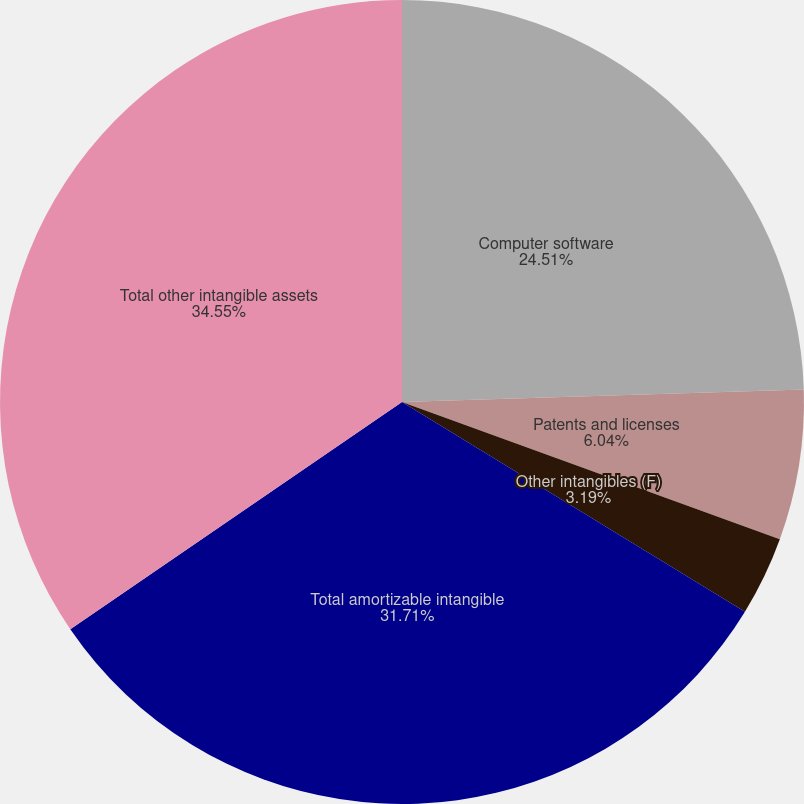<chart> <loc_0><loc_0><loc_500><loc_500><pie_chart><fcel>Computer software<fcel>Patents and licenses<fcel>Other intangibles (F)<fcel>Total amortizable intangible<fcel>Total other intangible assets<nl><fcel>24.51%<fcel>6.04%<fcel>3.19%<fcel>31.71%<fcel>34.56%<nl></chart> 